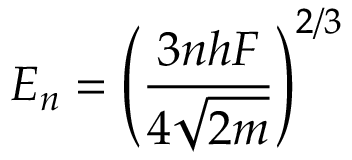<formula> <loc_0><loc_0><loc_500><loc_500>E _ { n } = \left ( { \frac { 3 n h F } { 4 { \sqrt { 2 m } } } } \right ) ^ { 2 / 3 }</formula> 